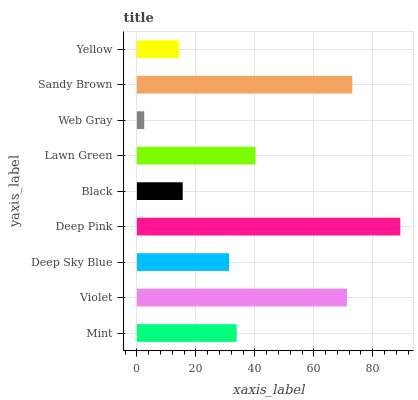Is Web Gray the minimum?
Answer yes or no. Yes. Is Deep Pink the maximum?
Answer yes or no. Yes. Is Violet the minimum?
Answer yes or no. No. Is Violet the maximum?
Answer yes or no. No. Is Violet greater than Mint?
Answer yes or no. Yes. Is Mint less than Violet?
Answer yes or no. Yes. Is Mint greater than Violet?
Answer yes or no. No. Is Violet less than Mint?
Answer yes or no. No. Is Mint the high median?
Answer yes or no. Yes. Is Mint the low median?
Answer yes or no. Yes. Is Black the high median?
Answer yes or no. No. Is Sandy Brown the low median?
Answer yes or no. No. 